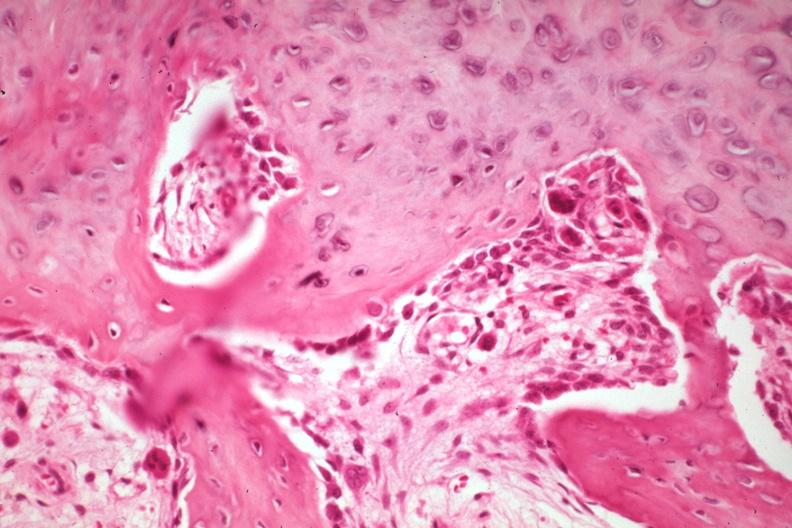does this image show high new bone formation with osteoblasts and osteoclasts a good but not the best example?
Answer the question using a single word or phrase. Yes 